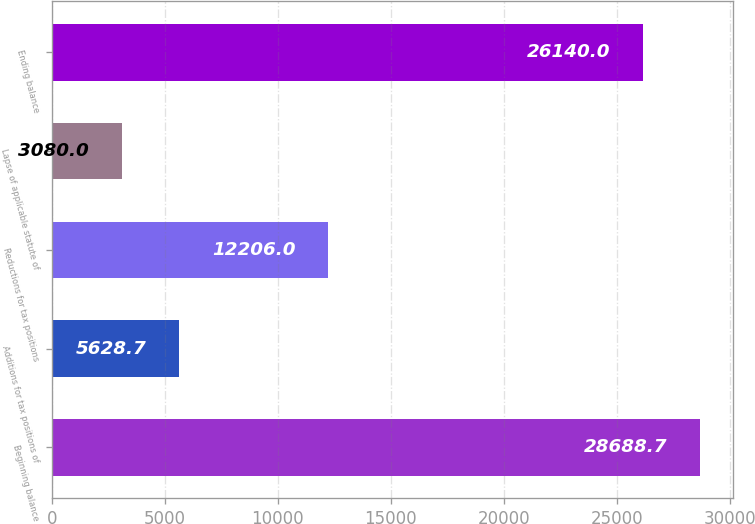<chart> <loc_0><loc_0><loc_500><loc_500><bar_chart><fcel>Beginning balance<fcel>Additions for tax positions of<fcel>Reductions for tax positions<fcel>Lapse of applicable statute of<fcel>Ending balance<nl><fcel>28688.7<fcel>5628.7<fcel>12206<fcel>3080<fcel>26140<nl></chart> 